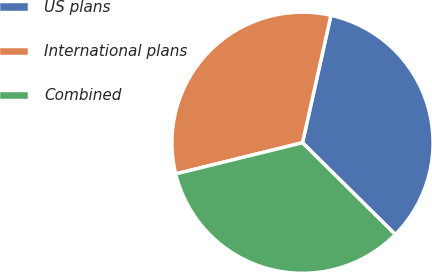Convert chart. <chart><loc_0><loc_0><loc_500><loc_500><pie_chart><fcel>US plans<fcel>International plans<fcel>Combined<nl><fcel>33.91%<fcel>32.33%<fcel>33.75%<nl></chart> 